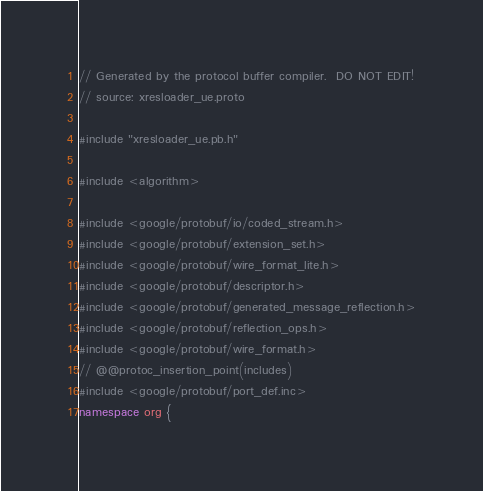<code> <loc_0><loc_0><loc_500><loc_500><_C++_>// Generated by the protocol buffer compiler.  DO NOT EDIT!
// source: xresloader_ue.proto

#include "xresloader_ue.pb.h"

#include <algorithm>

#include <google/protobuf/io/coded_stream.h>
#include <google/protobuf/extension_set.h>
#include <google/protobuf/wire_format_lite.h>
#include <google/protobuf/descriptor.h>
#include <google/protobuf/generated_message_reflection.h>
#include <google/protobuf/reflection_ops.h>
#include <google/protobuf/wire_format.h>
// @@protoc_insertion_point(includes)
#include <google/protobuf/port_def.inc>
namespace org {</code> 